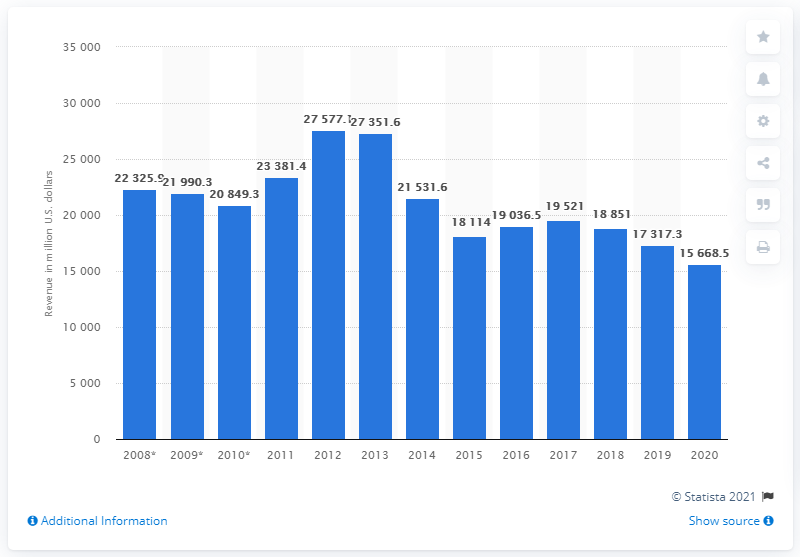Indicate a few pertinent items in this graphic. In the year 2019, Fluor Corporation was one of the biggest construction firms worldwide. The revenue of Fluor Corporation in the year before was 17,317.3... The contractor's revenue in the fiscal year of 2020 was 15668.5. 